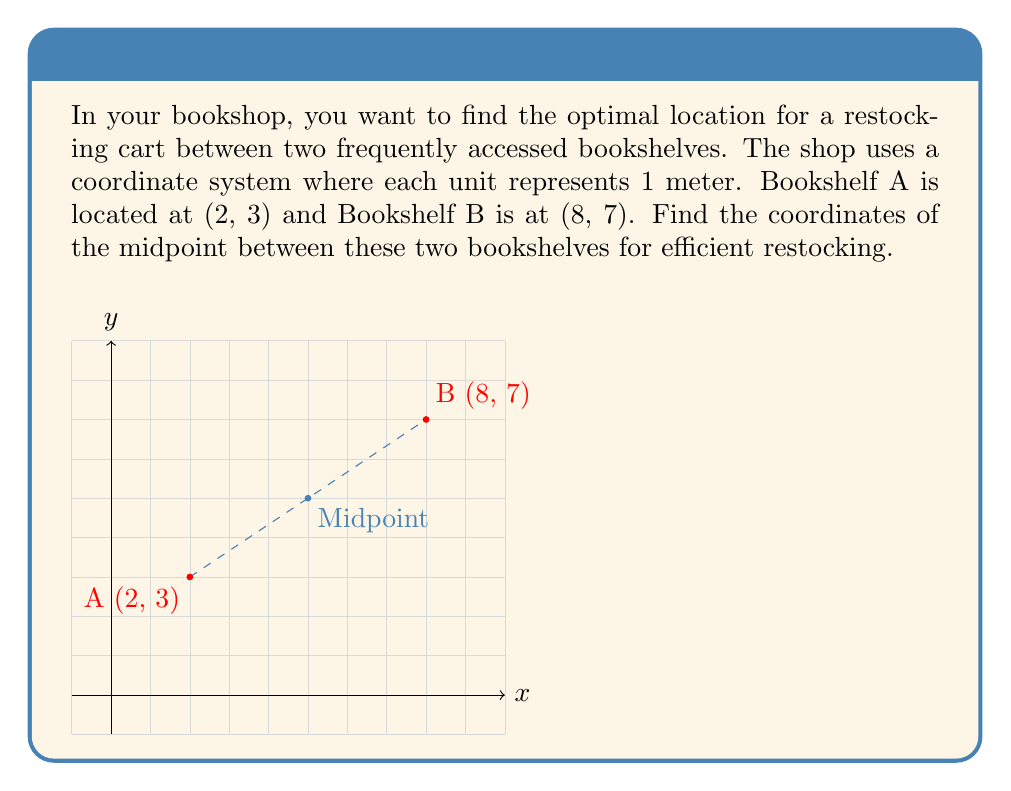What is the answer to this math problem? To find the midpoint between two points in a coordinate system, we use the midpoint formula:

$$ \text{Midpoint} = \left(\frac{x_1 + x_2}{2}, \frac{y_1 + y_2}{2}\right) $$

Where $(x_1, y_1)$ are the coordinates of the first point and $(x_2, y_2)$ are the coordinates of the second point.

For our bookshelf locations:
- Bookshelf A: $(x_1, y_1) = (2, 3)$
- Bookshelf B: $(x_2, y_2) = (8, 7)$

Let's calculate the x-coordinate of the midpoint:
$$ x = \frac{x_1 + x_2}{2} = \frac{2 + 8}{2} = \frac{10}{2} = 5 $$

Now, let's calculate the y-coordinate of the midpoint:
$$ y = \frac{y_1 + y_2}{2} = \frac{3 + 7}{2} = \frac{10}{2} = 5 $$

Therefore, the midpoint coordinates are (5, 5).
Answer: (5, 5) 